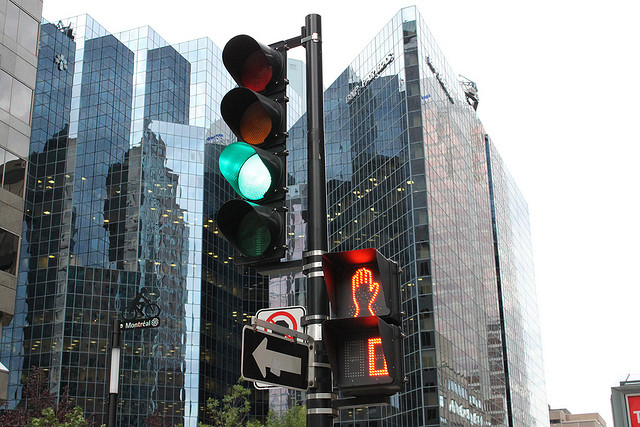What color is the pedestrian signal showing? The pedestrian signal in the image is displaying a red figure, which means do not walk. 